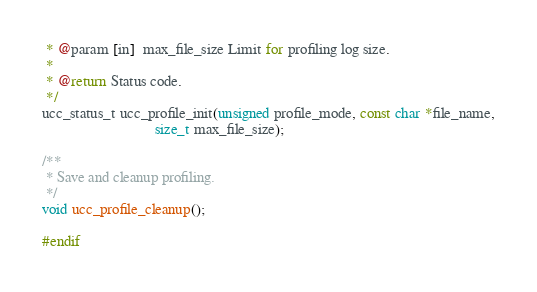Convert code to text. <code><loc_0><loc_0><loc_500><loc_500><_C_> * @param [in]  max_file_size Limit for profiling log size.
 *
 * @return Status code.
 */
ucc_status_t ucc_profile_init(unsigned profile_mode, const char *file_name,
                              size_t max_file_size);

/**
 * Save and cleanup profiling.
 */
void ucc_profile_cleanup();

#endif
</code> 